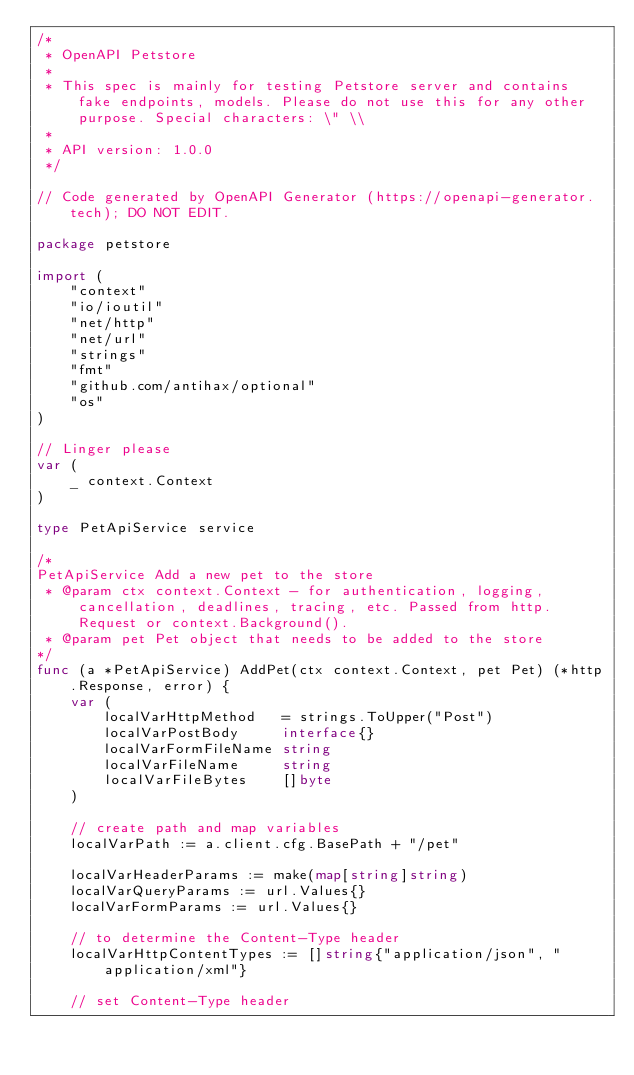<code> <loc_0><loc_0><loc_500><loc_500><_Go_>/*
 * OpenAPI Petstore
 *
 * This spec is mainly for testing Petstore server and contains fake endpoints, models. Please do not use this for any other purpose. Special characters: \" \\
 *
 * API version: 1.0.0
 */

// Code generated by OpenAPI Generator (https://openapi-generator.tech); DO NOT EDIT.

package petstore

import (
	"context"
	"io/ioutil"
	"net/http"
	"net/url"
	"strings"
	"fmt"
	"github.com/antihax/optional"
	"os"
)

// Linger please
var (
	_ context.Context
)

type PetApiService service

/*
PetApiService Add a new pet to the store
 * @param ctx context.Context - for authentication, logging, cancellation, deadlines, tracing, etc. Passed from http.Request or context.Background().
 * @param pet Pet object that needs to be added to the store
*/
func (a *PetApiService) AddPet(ctx context.Context, pet Pet) (*http.Response, error) {
	var (
		localVarHttpMethod   = strings.ToUpper("Post")
		localVarPostBody     interface{}
		localVarFormFileName string
		localVarFileName     string
		localVarFileBytes    []byte
	)

	// create path and map variables
	localVarPath := a.client.cfg.BasePath + "/pet"

	localVarHeaderParams := make(map[string]string)
	localVarQueryParams := url.Values{}
	localVarFormParams := url.Values{}

	// to determine the Content-Type header
	localVarHttpContentTypes := []string{"application/json", "application/xml"}

	// set Content-Type header</code> 